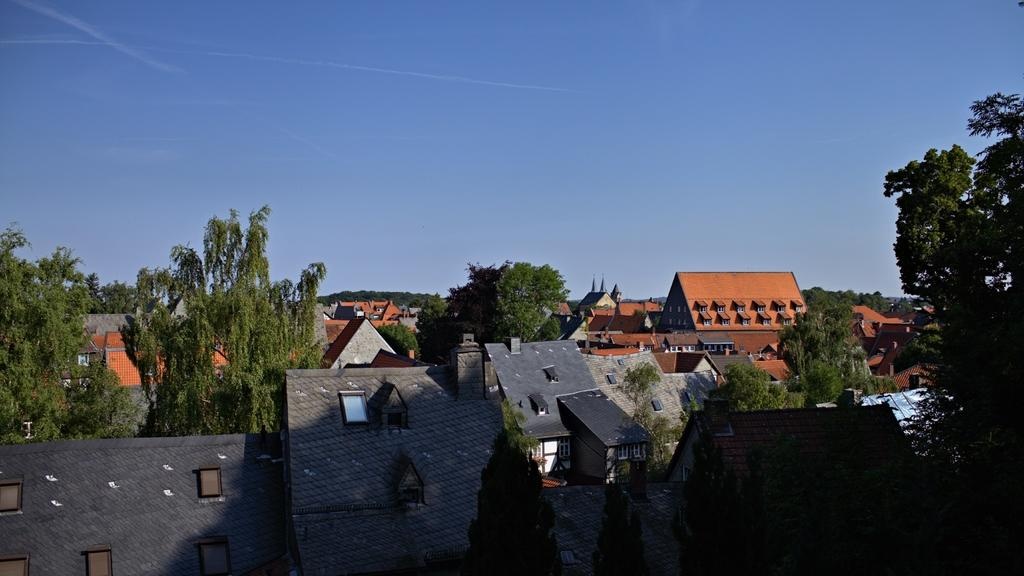What type of view is shown in the image? The image is an aerial view. What structures can be seen in the image? There are buildings in the image. What part of the buildings is visible in the image? Roofs are visible in the image. What architectural feature is present in the buildings? Windows are present in the image. What type of natural element is visible in the image? Trees are present in the image. What is visible at the top of the image? Clouds are visible at the top of the image in the sky. How many laborers are working on the roof of the building in the image? There are no laborers present in the image; it is an aerial view of buildings, trees, and clouds. 